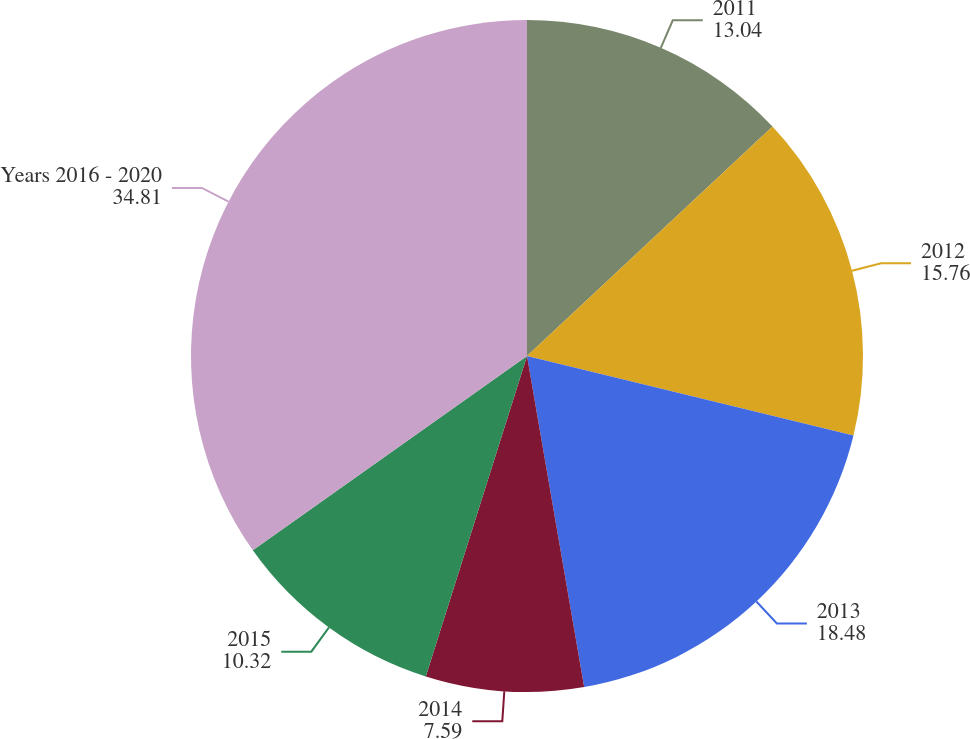Convert chart to OTSL. <chart><loc_0><loc_0><loc_500><loc_500><pie_chart><fcel>2011<fcel>2012<fcel>2013<fcel>2014<fcel>2015<fcel>Years 2016 - 2020<nl><fcel>13.04%<fcel>15.76%<fcel>18.48%<fcel>7.59%<fcel>10.32%<fcel>34.81%<nl></chart> 